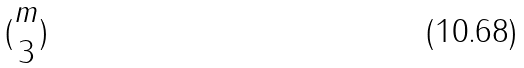Convert formula to latex. <formula><loc_0><loc_0><loc_500><loc_500>( \begin{matrix} m \\ 3 \end{matrix} )</formula> 